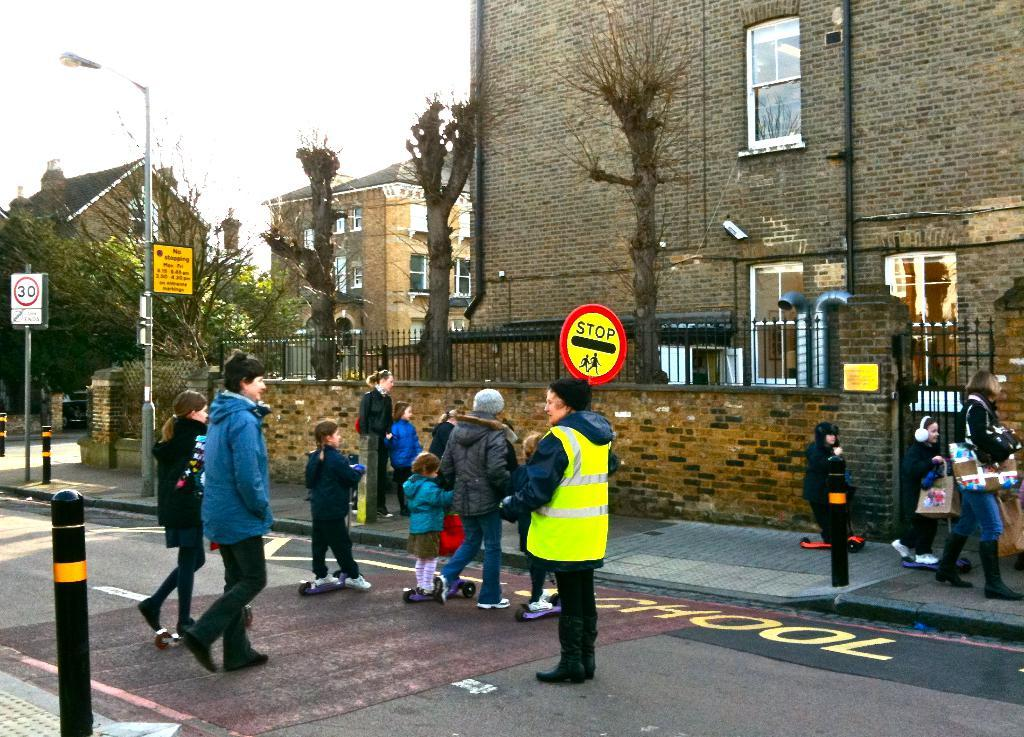What are the people in the image doing? The people in the image are crossing the road. Who is present in the image besides the people crossing the road? A police officer is present in the image. What is the police officer wearing? The police officer is wearing a green coat. What can be seen on the right side of the image? There is a building on the right side of the image. What type of vegetation is on the left side of the image? There are trees on the left side of the image. What type of reward is the police officer holding in the image? There is no reward visible in the image; the police officer is wearing a green coat and not holding anything. 